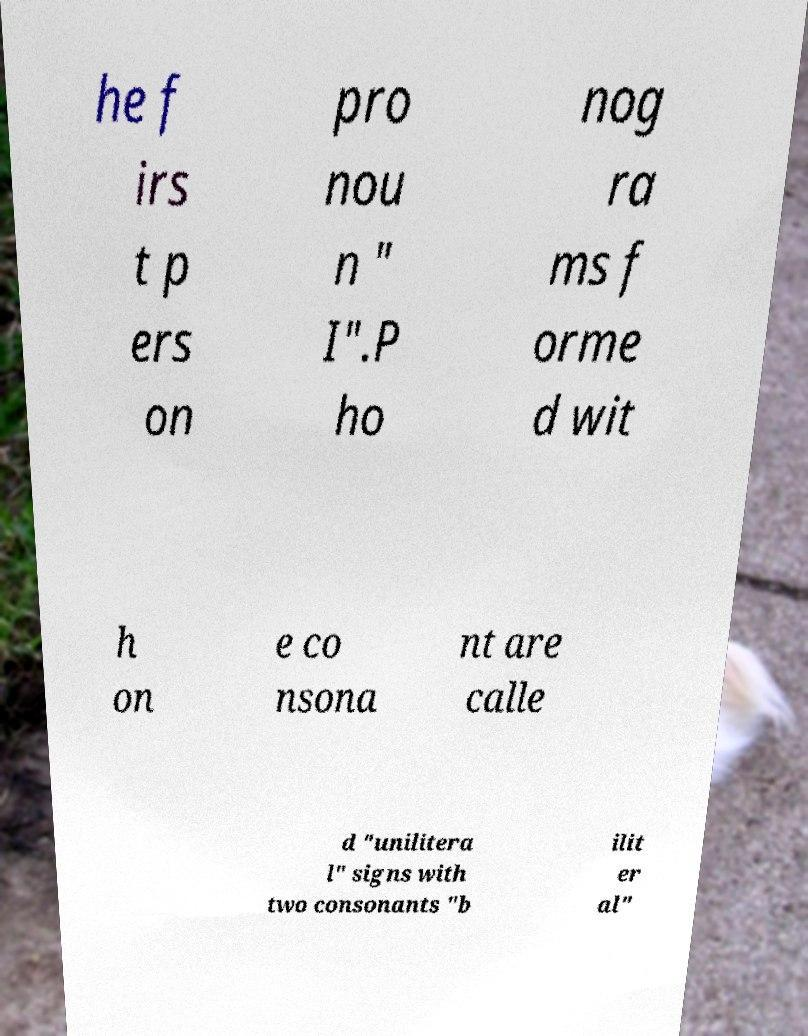Can you accurately transcribe the text from the provided image for me? he f irs t p ers on pro nou n " I".P ho nog ra ms f orme d wit h on e co nsona nt are calle d "unilitera l" signs with two consonants "b ilit er al" 